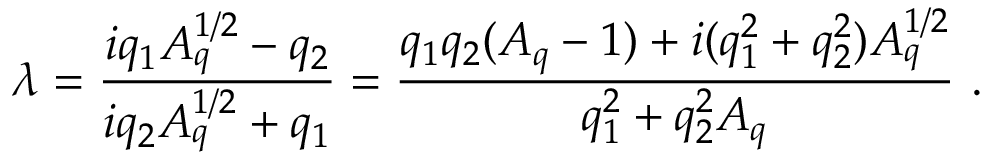<formula> <loc_0><loc_0><loc_500><loc_500>\lambda = { \frac { i q _ { 1 } A _ { q } ^ { 1 / 2 } - q _ { 2 } } { i q _ { 2 } A _ { q } ^ { 1 / 2 } + q _ { 1 } } } = { \frac { q _ { 1 } q _ { 2 } ( A _ { q } - 1 ) + i ( q _ { 1 } ^ { 2 } + q _ { 2 } ^ { 2 } ) A _ { q } ^ { 1 / 2 } } { q _ { 1 } ^ { 2 } + q _ { 2 } ^ { 2 } A _ { q } } } \ .</formula> 